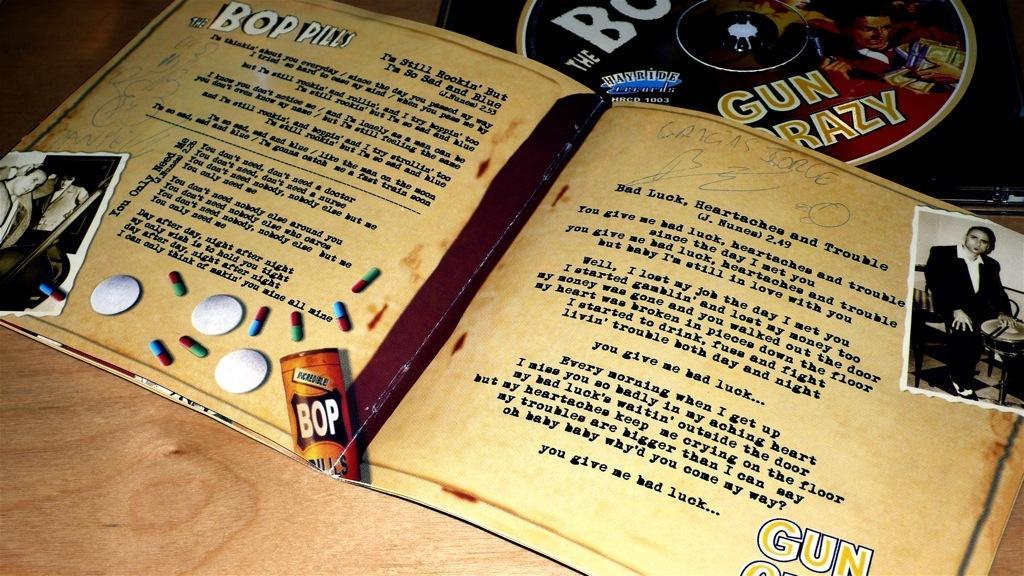Describe this image in one or two sentences. On this wooden surface we can see a book and compact disc. In these pictures we can see people. 